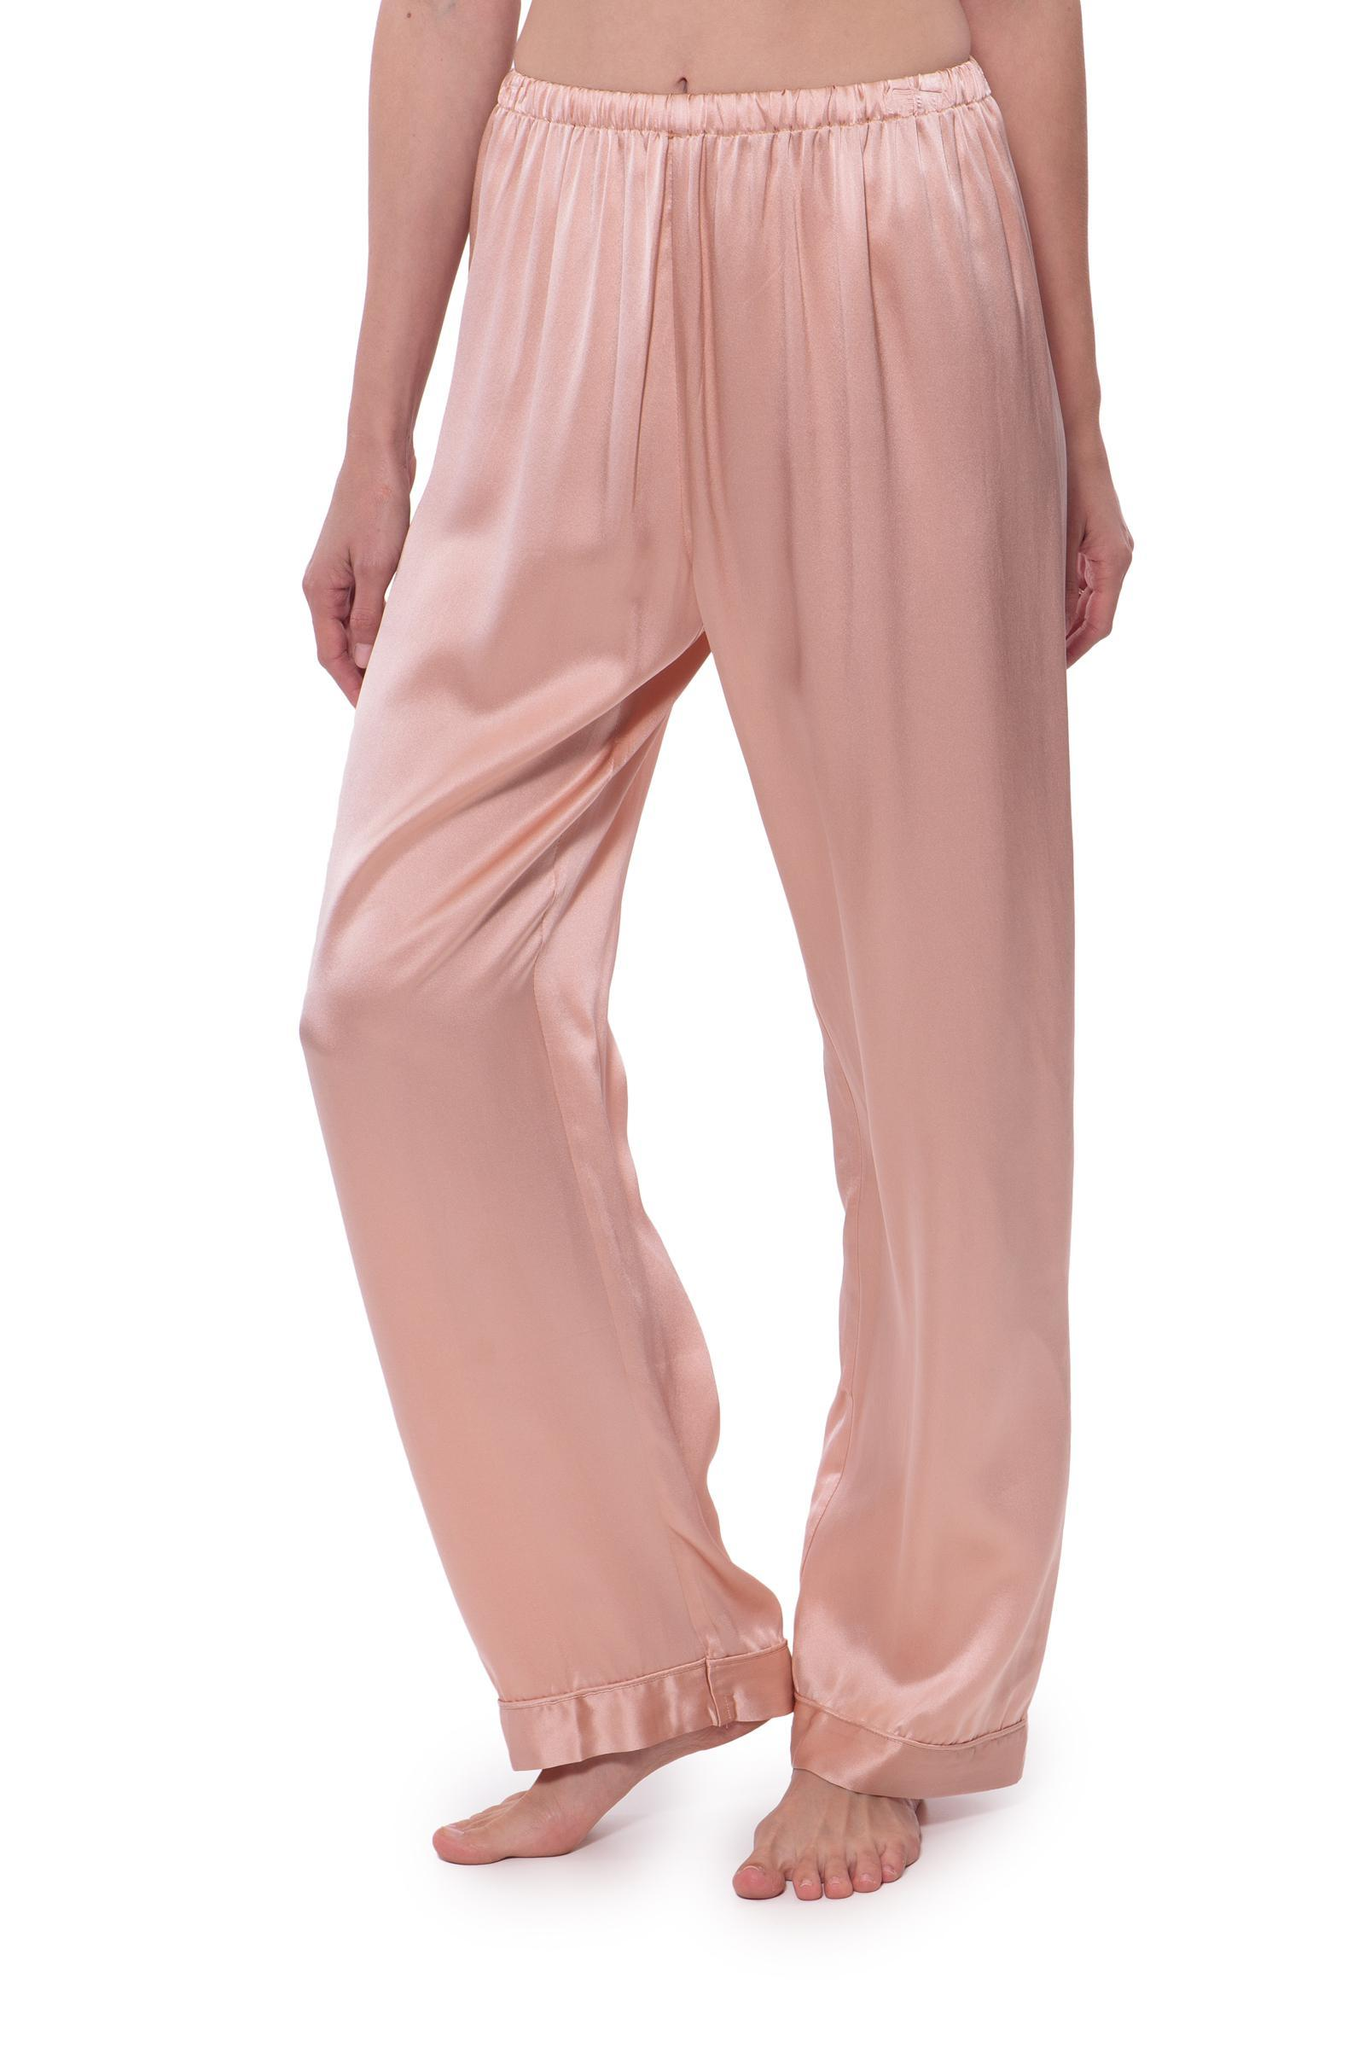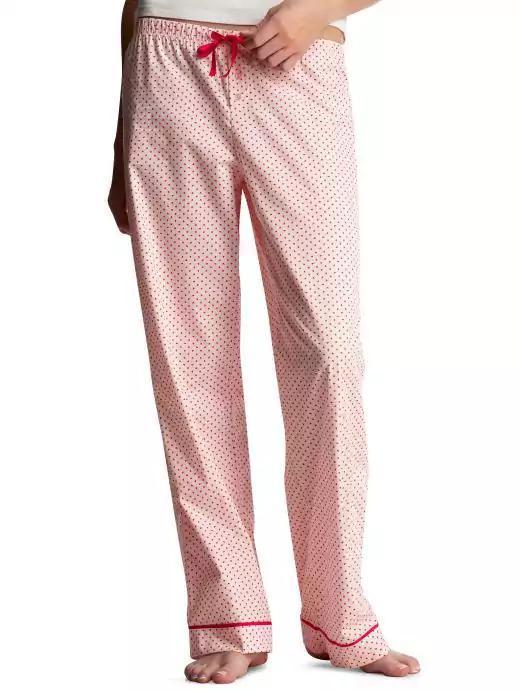The first image is the image on the left, the second image is the image on the right. Given the left and right images, does the statement "The left image shows a woman modeling matching pajama top and bottom." hold true? Answer yes or no. No. 